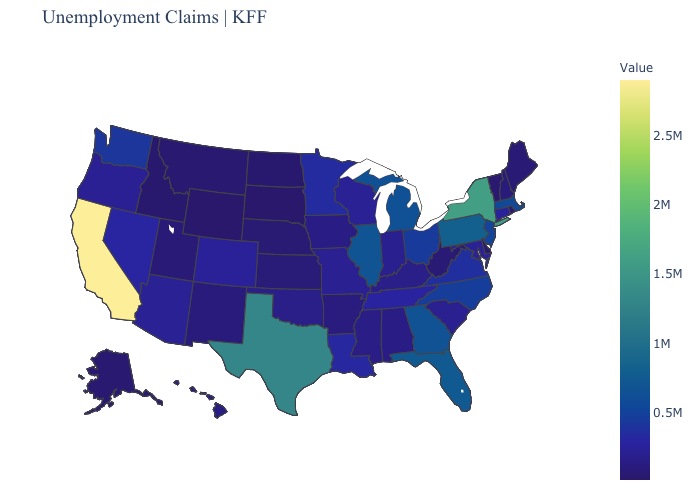Which states hav the highest value in the Northeast?
Give a very brief answer. New York. Does Ohio have a higher value than Utah?
Keep it brief. Yes. Does Vermont have the lowest value in the Northeast?
Keep it brief. Yes. Does South Dakota have the lowest value in the MidWest?
Short answer required. Yes. Among the states that border Delaware , which have the highest value?
Be succinct. Pennsylvania. 